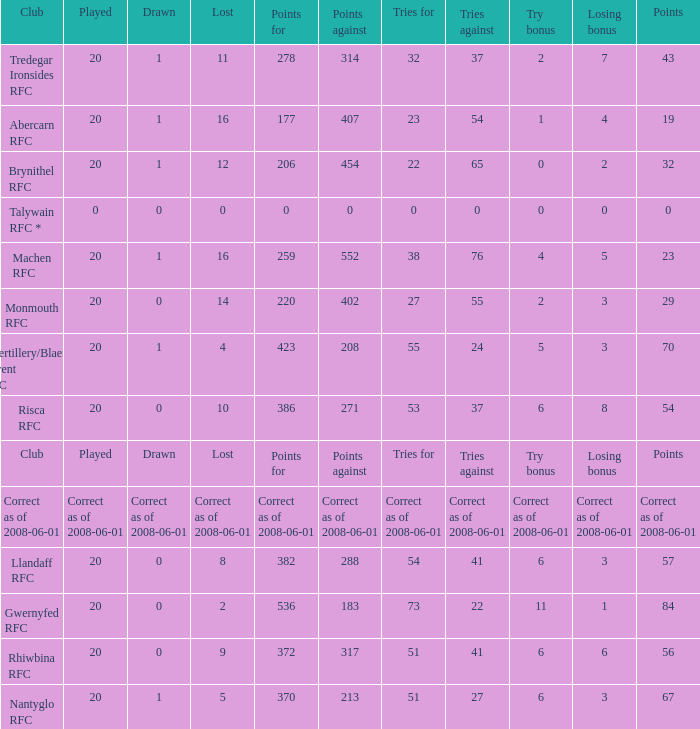Name the tries when tries against were 41, try bonus was 6, and had 317 points. 51.0. 